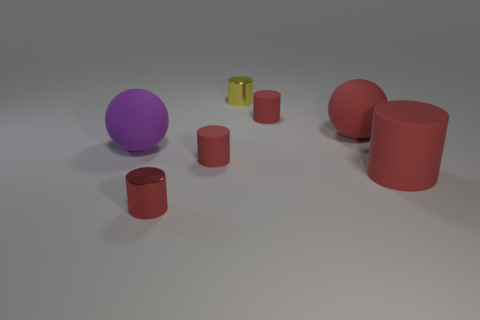What material is the large purple sphere?
Your answer should be compact. Rubber. Does the purple ball have the same material as the tiny red object on the right side of the tiny yellow metallic thing?
Offer a very short reply. Yes. There is a metal thing that is behind the big rubber object that is right of the large red sphere; what color is it?
Give a very brief answer. Yellow. There is a red matte cylinder that is both to the right of the tiny yellow metallic object and behind the large cylinder; how big is it?
Provide a succinct answer. Small. What number of other objects are the same shape as the yellow metal object?
Keep it short and to the point. 4. Do the purple thing and the tiny matte thing in front of the purple sphere have the same shape?
Offer a very short reply. No. How many big things are left of the large red matte cylinder?
Offer a terse response. 2. Is there anything else that is the same material as the big red cylinder?
Give a very brief answer. Yes. Is the shape of the small matte object right of the small yellow cylinder the same as  the yellow metallic thing?
Your answer should be compact. Yes. What color is the shiny thing in front of the purple rubber ball?
Provide a succinct answer. Red. 